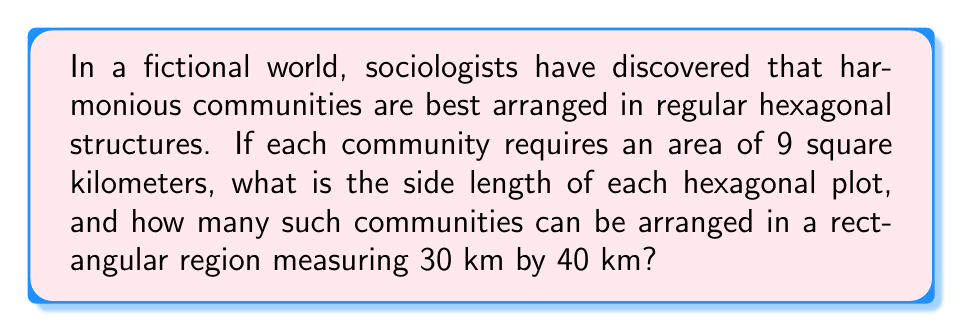Could you help me with this problem? 1. Calculate the side length of the hexagonal plot:
   The area of a regular hexagon is given by $A = \frac{3\sqrt{3}}{2}s^2$, where $s$ is the side length.
   Given $A = 9$ km², we have:
   $$9 = \frac{3\sqrt{3}}{2}s^2$$
   $$s^2 = \frac{18}{3\sqrt{3}} = \frac{6}{\sqrt{3}}$$
   $$s = \sqrt{\frac{6}{\sqrt{3}}} = \sqrt{2\sqrt{3}} \approx 1.902$ km

2. Calculate the width and height of a hexagon:
   Width = $2s = 2\sqrt{2\sqrt{3}} \approx 3.804$ km
   Height = $\sqrt{3}s = \sqrt{3}\sqrt{2\sqrt{3}} \approx 3.291$ km

3. Determine how many hexagons fit in the rectangular region:
   Columns: $\lfloor 30 / (2s) \rfloor = \lfloor 30 / (2\sqrt{2\sqrt{3}}) \rfloor = 7$
   Rows: $\lfloor 40 / (\sqrt{3}s) \rfloor = \lfloor 40 / (\sqrt{3}\sqrt{2\sqrt{3}}) \rfloor = 12$

4. Calculate total number of hexagons:
   In even rows: 7 hexagons
   In odd rows: 8 hexagons
   Total = $6 \times 7 + 6 \times 8 = 90$ hexagons

[asy]
import geometry;

unitsize(10mm);
real s = sqrt(2*sqrt(3));
path hex = polygon(6);
for(int i = 0; i < 7; ++i) {
  for(int j = 0; j < 12; ++j) {
    shift((i*2 + j%2)*s, j*sqrt(3)*s)*hex;
  }
}
draw(box((0,0), (15.8,19.7)));
label("30 km", (7.9,-0.5));
label("40 km", (16.3,9.85), E);
[/asy]
Answer: Side length: $\sqrt{2\sqrt{3}}$ km; 90 communities 